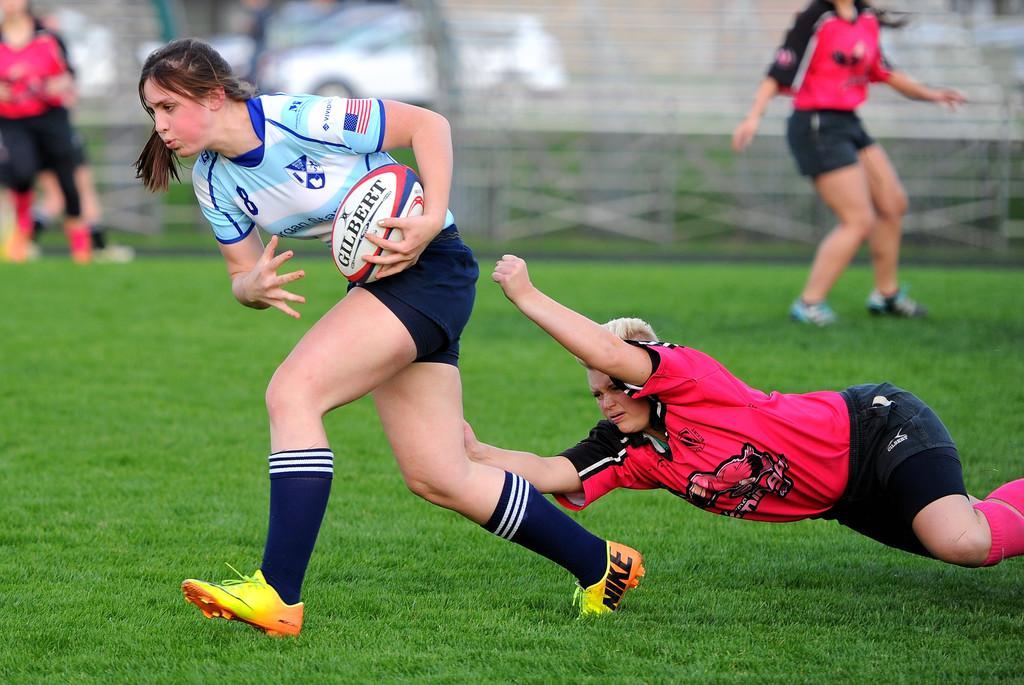What are the persons in the image doing? The persons in the image are playing a game. What object is involved in the game? There is a ball in the image. Can you describe the woman in the background? The woman in the background is wearing a blue jersey. What can be seen behind the people playing the game? There is a wall in the background of the image. What type of dress is the governor wearing in the image? There is no governor present in the image, and therefore no dress to describe. 